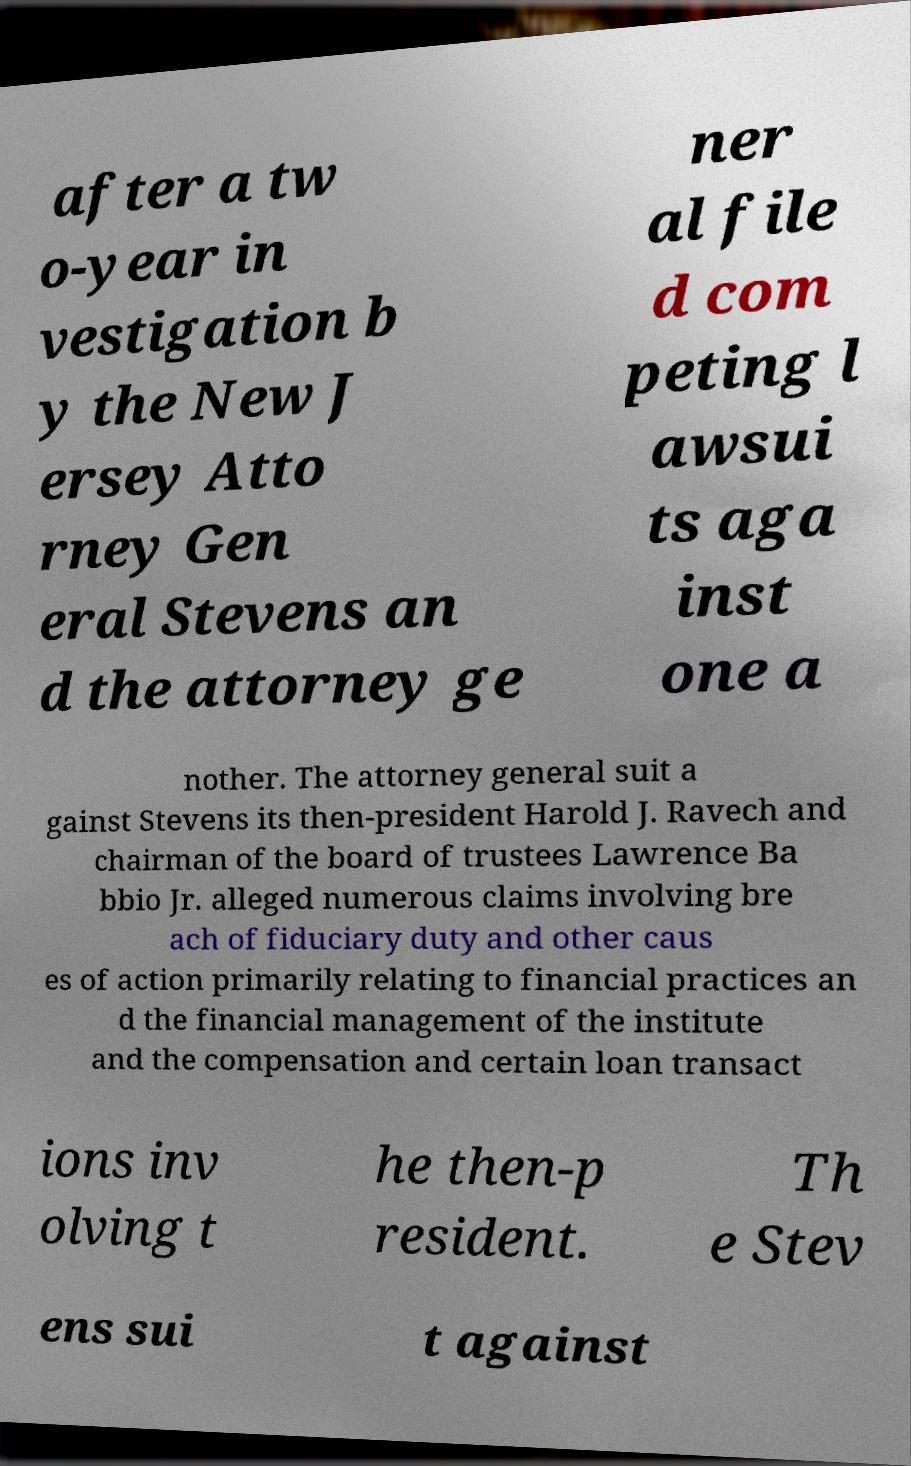Please identify and transcribe the text found in this image. after a tw o-year in vestigation b y the New J ersey Atto rney Gen eral Stevens an d the attorney ge ner al file d com peting l awsui ts aga inst one a nother. The attorney general suit a gainst Stevens its then-president Harold J. Ravech and chairman of the board of trustees Lawrence Ba bbio Jr. alleged numerous claims involving bre ach of fiduciary duty and other caus es of action primarily relating to financial practices an d the financial management of the institute and the compensation and certain loan transact ions inv olving t he then-p resident. Th e Stev ens sui t against 